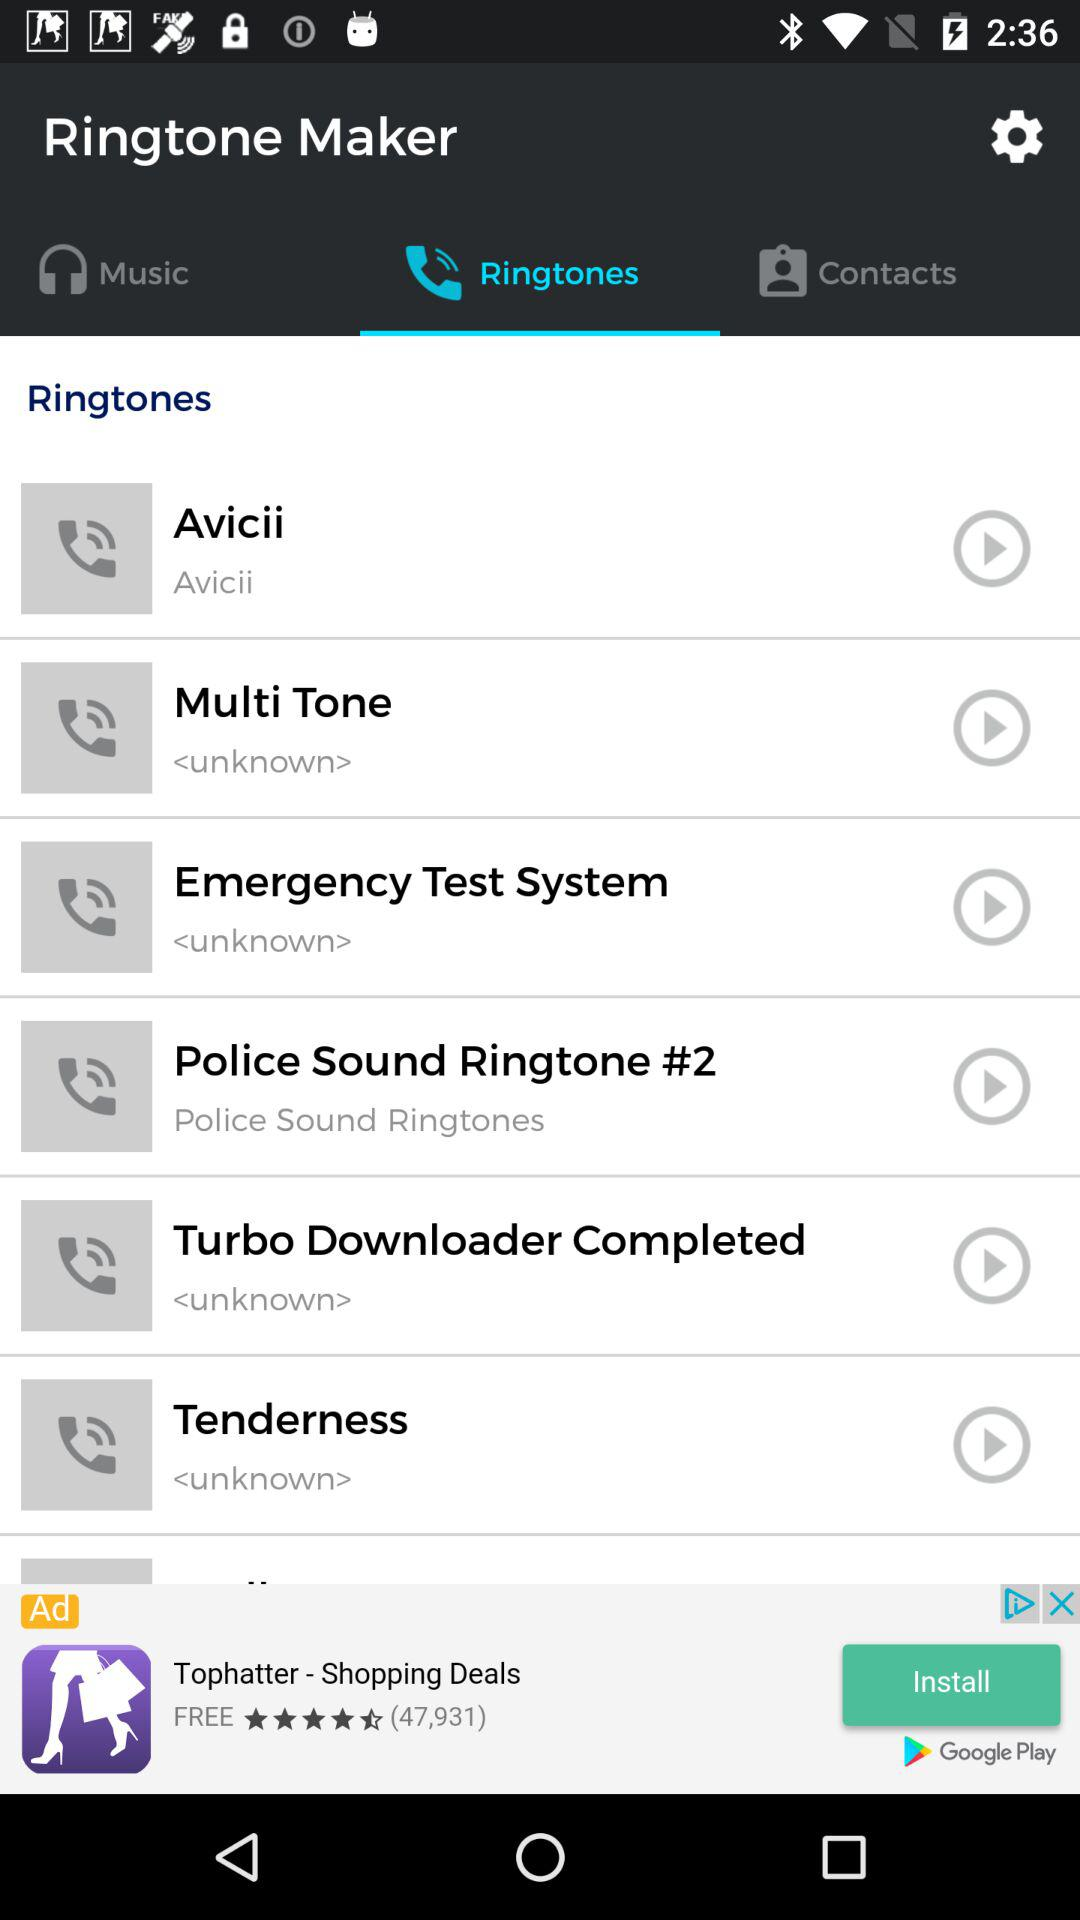How many ringtones are there?
Answer the question using a single word or phrase. 6 